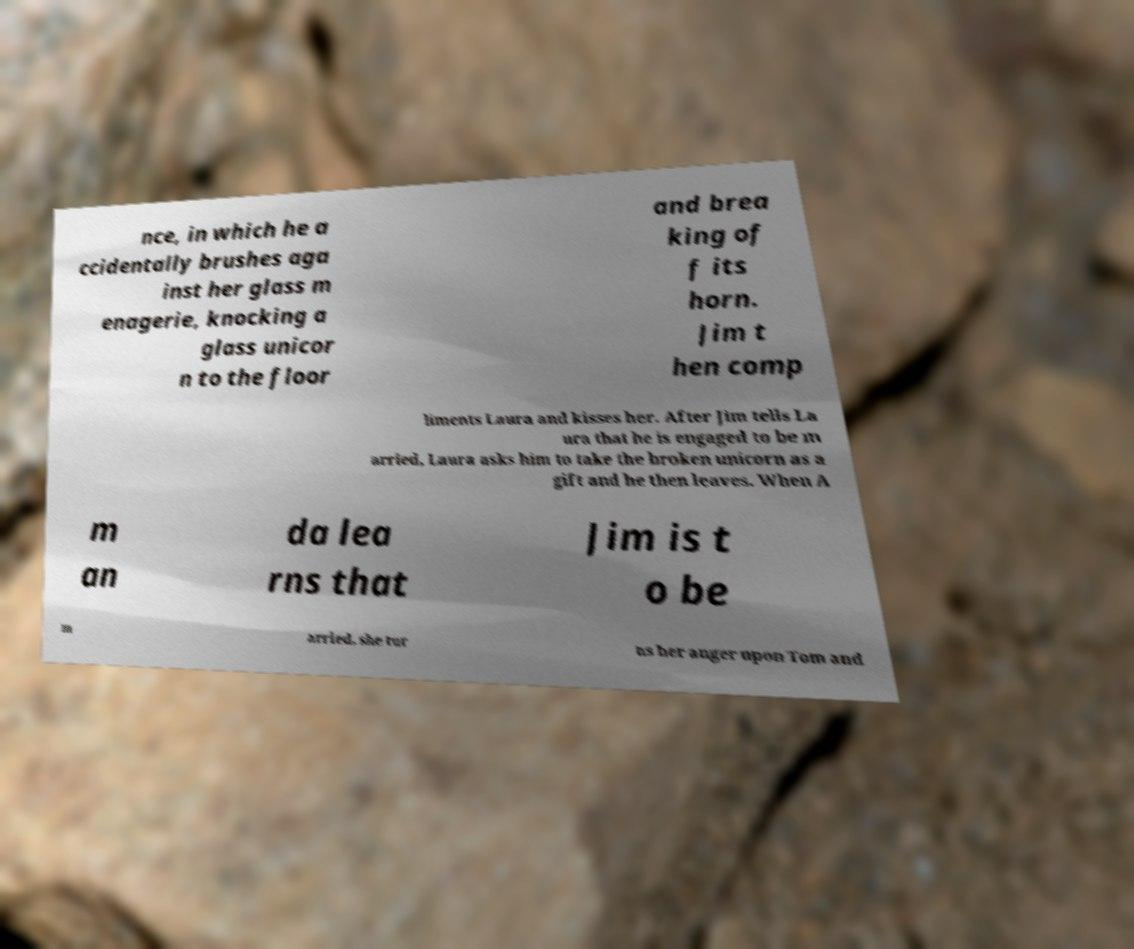Can you accurately transcribe the text from the provided image for me? nce, in which he a ccidentally brushes aga inst her glass m enagerie, knocking a glass unicor n to the floor and brea king of f its horn. Jim t hen comp liments Laura and kisses her. After Jim tells La ura that he is engaged to be m arried, Laura asks him to take the broken unicorn as a gift and he then leaves. When A m an da lea rns that Jim is t o be m arried, she tur ns her anger upon Tom and 